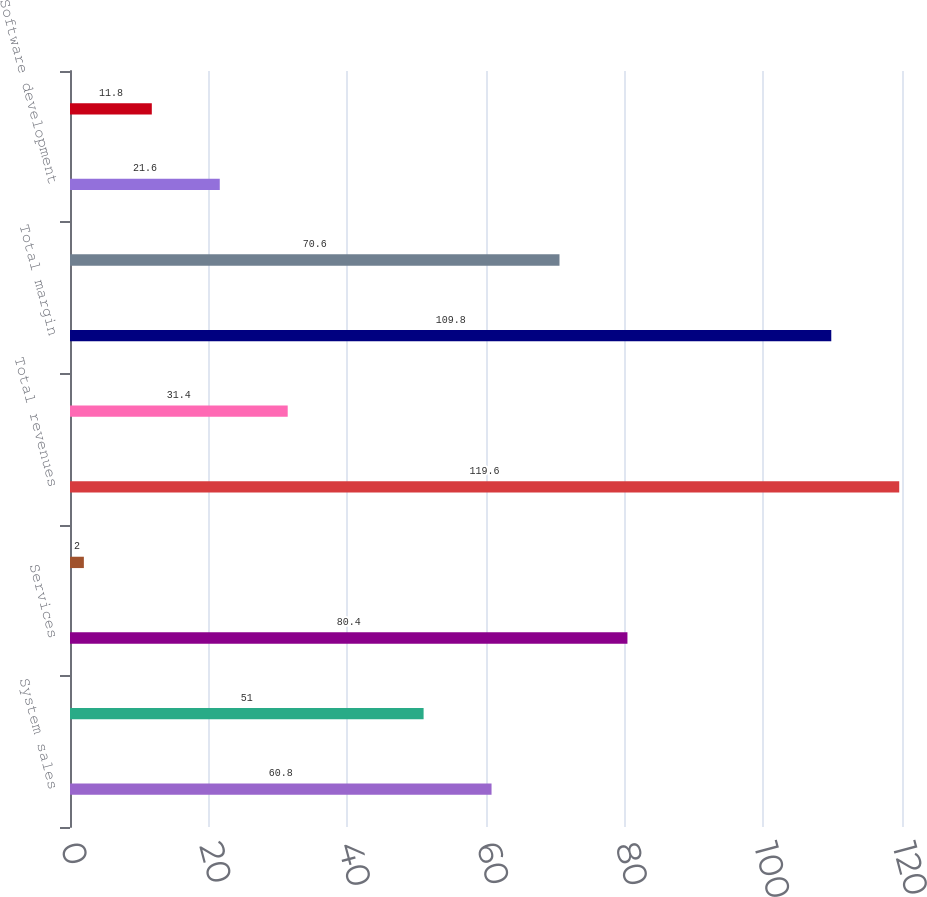<chart> <loc_0><loc_0><loc_500><loc_500><bar_chart><fcel>System sales<fcel>Support and maintenance<fcel>Services<fcel>Reimbursed travel<fcel>Total revenues<fcel>Costs of revenue<fcel>Total margin<fcel>Sales and client service<fcel>Software development<fcel>General and administrative<nl><fcel>60.8<fcel>51<fcel>80.4<fcel>2<fcel>119.6<fcel>31.4<fcel>109.8<fcel>70.6<fcel>21.6<fcel>11.8<nl></chart> 